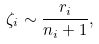<formula> <loc_0><loc_0><loc_500><loc_500>\zeta _ { i } \sim \frac { r _ { i } } { n _ { i } + 1 } ,</formula> 